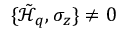<formula> <loc_0><loc_0><loc_500><loc_500>\{ \tilde { \mathcal { H } } _ { q } , \sigma _ { z } \} \neq 0</formula> 